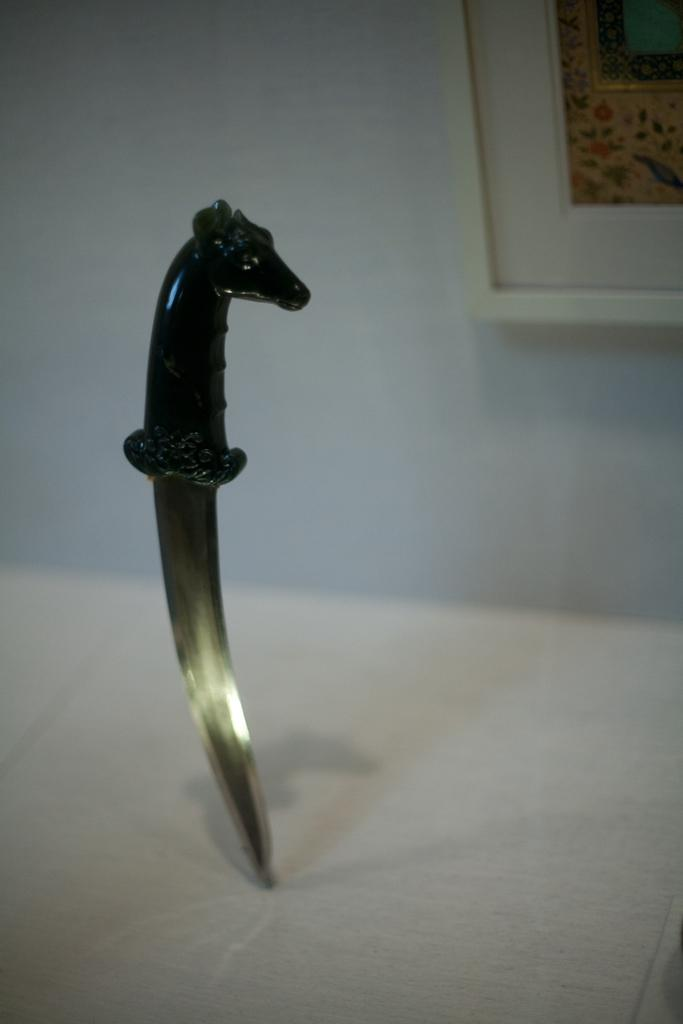What object is located in the foreground of the image? There is a knife in the foreground of the image. Where is the knife placed? The knife is on a surface. What can be seen in the background of the image? There is a frame on the wall in the background of the image. What type of statement can be seen written on the earth in the image? There is no statement written on the earth in the image, as the facts provided do not mention anything about the earth or any writing. 